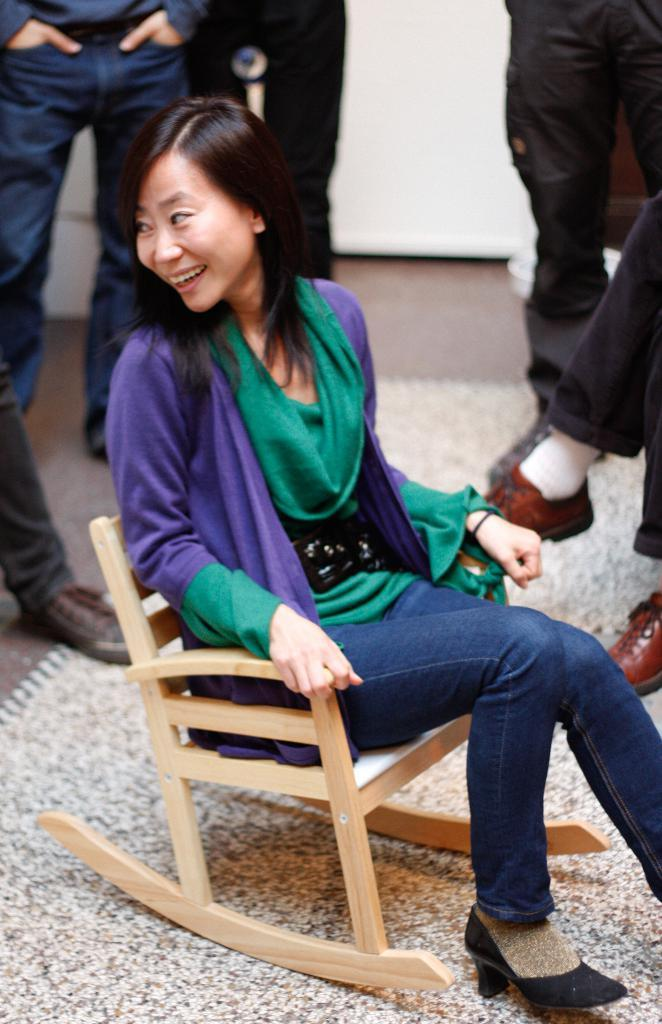Who is the main subject in the image? There is a woman in the image. What is the woman doing in the image? The woman is smiling in the image. What is the woman sitting on in the image? The woman is sitting on a chair in the image. Can you describe the people in the background of the image? The people in the background are standing in the image. What type of clam is the woman holding in the image? There is no clam present in the image; the woman is simply sitting and smiling. 